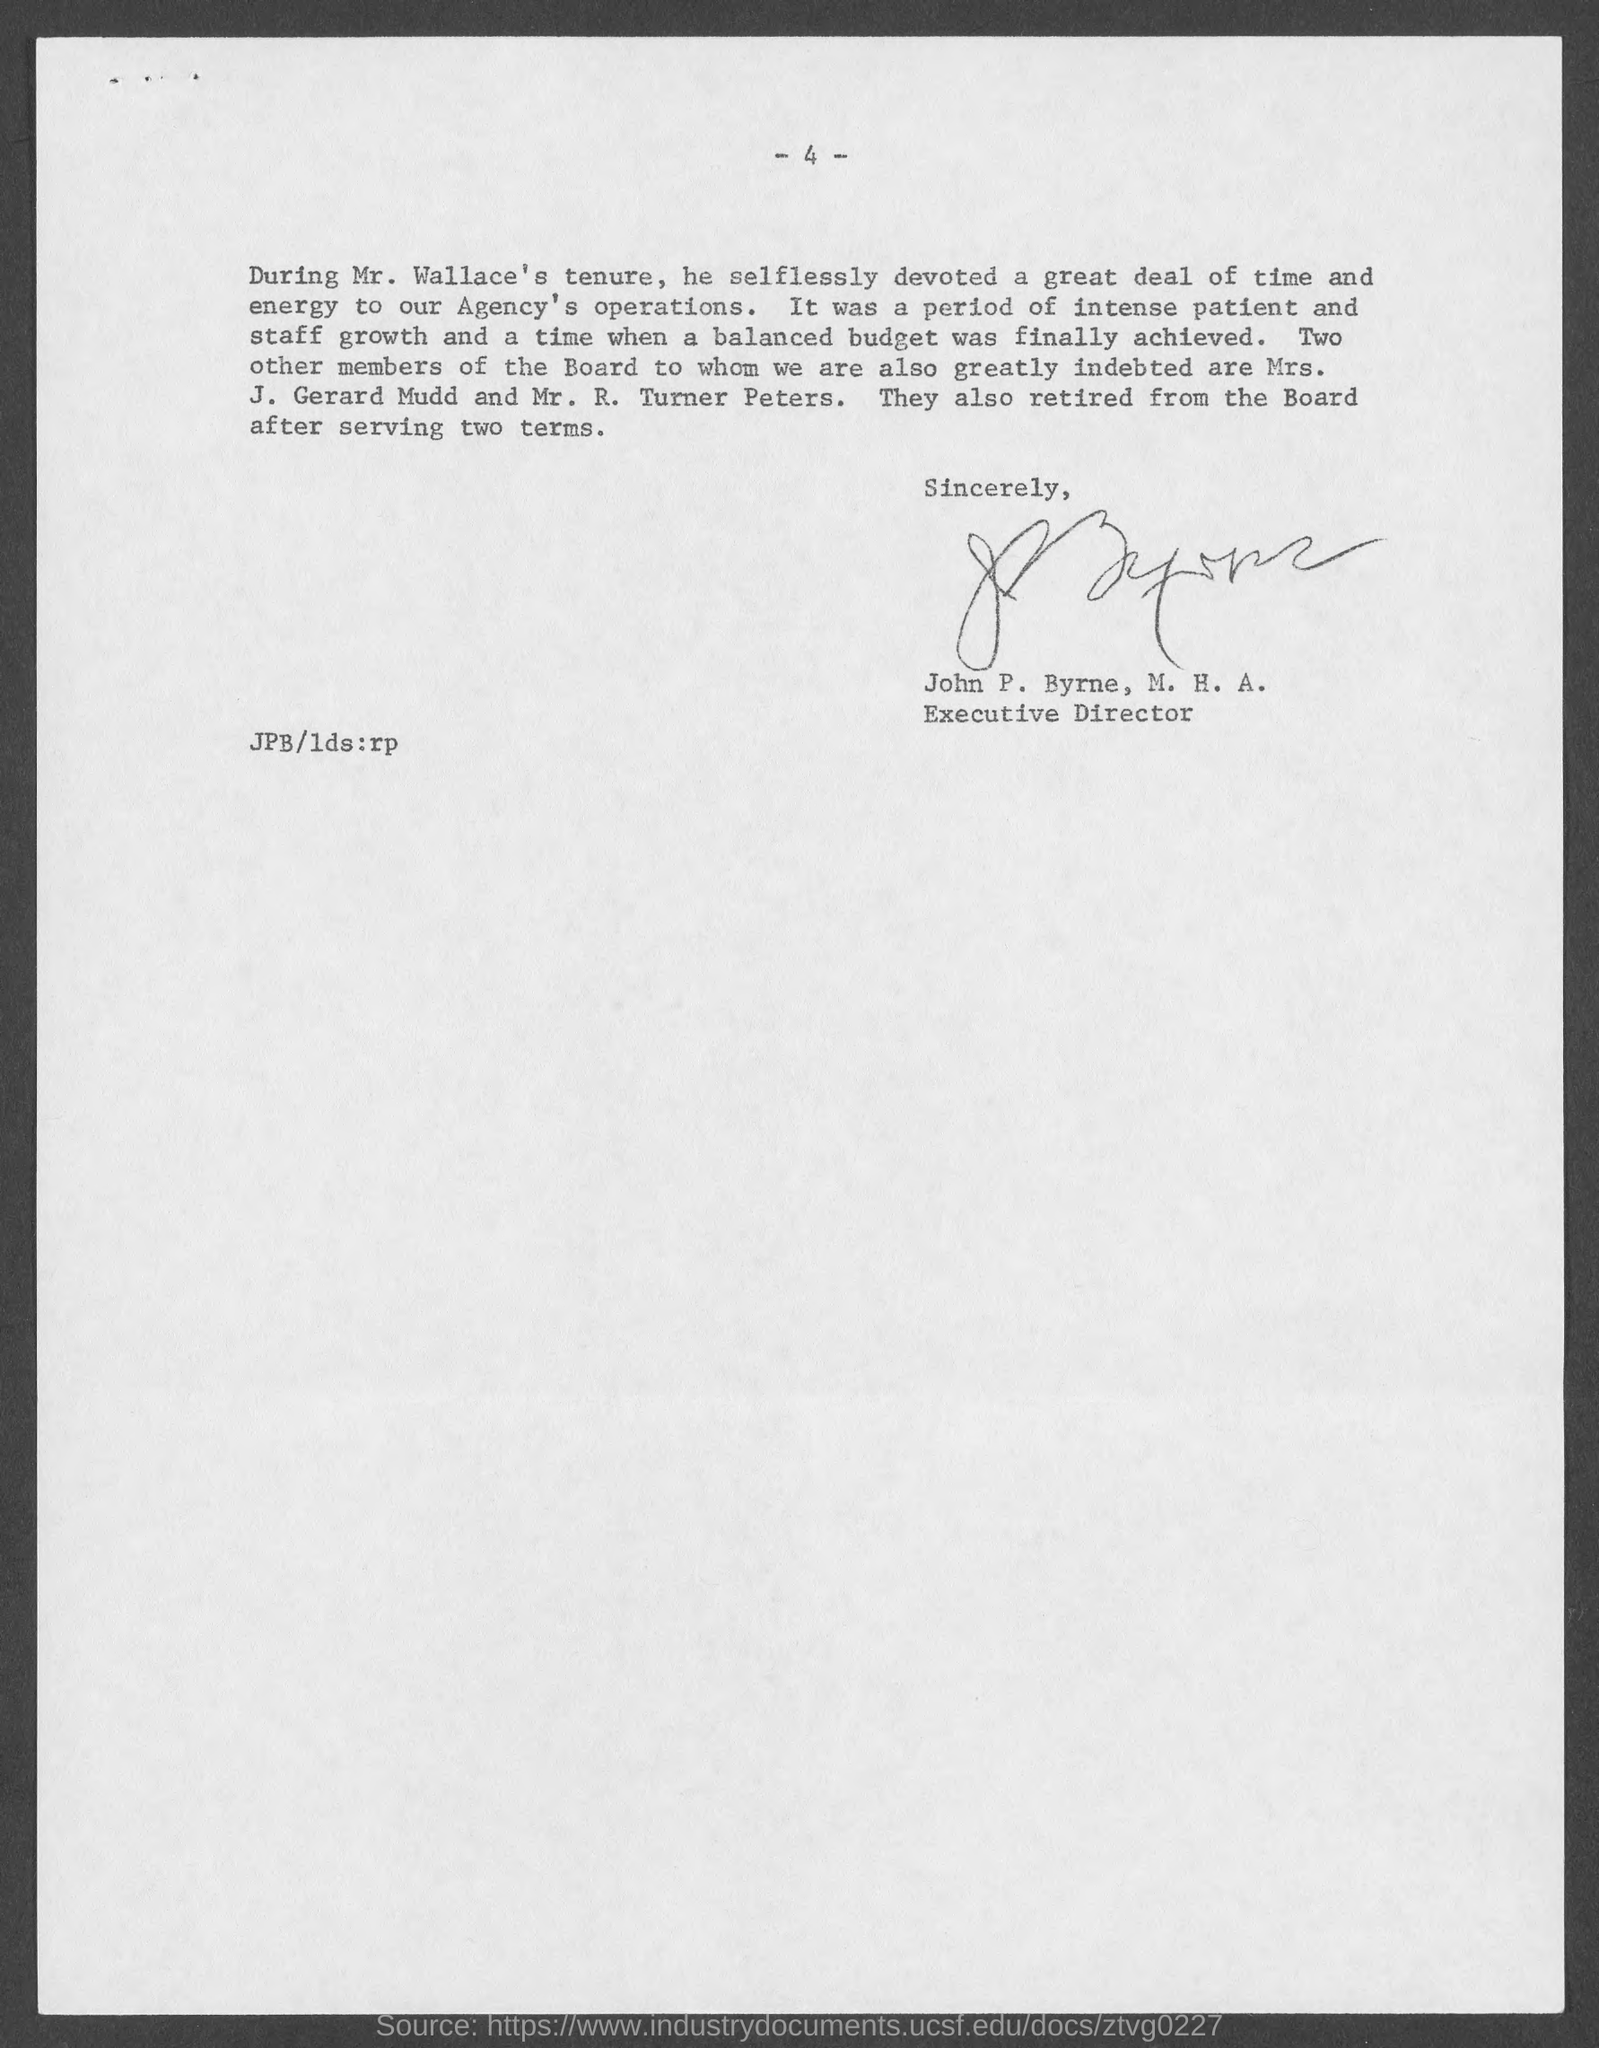List a handful of essential elements in this visual. The members who are indebted to the Board are Mrs. J. Gerard Mudd and Mr. R. Turner Peters. 